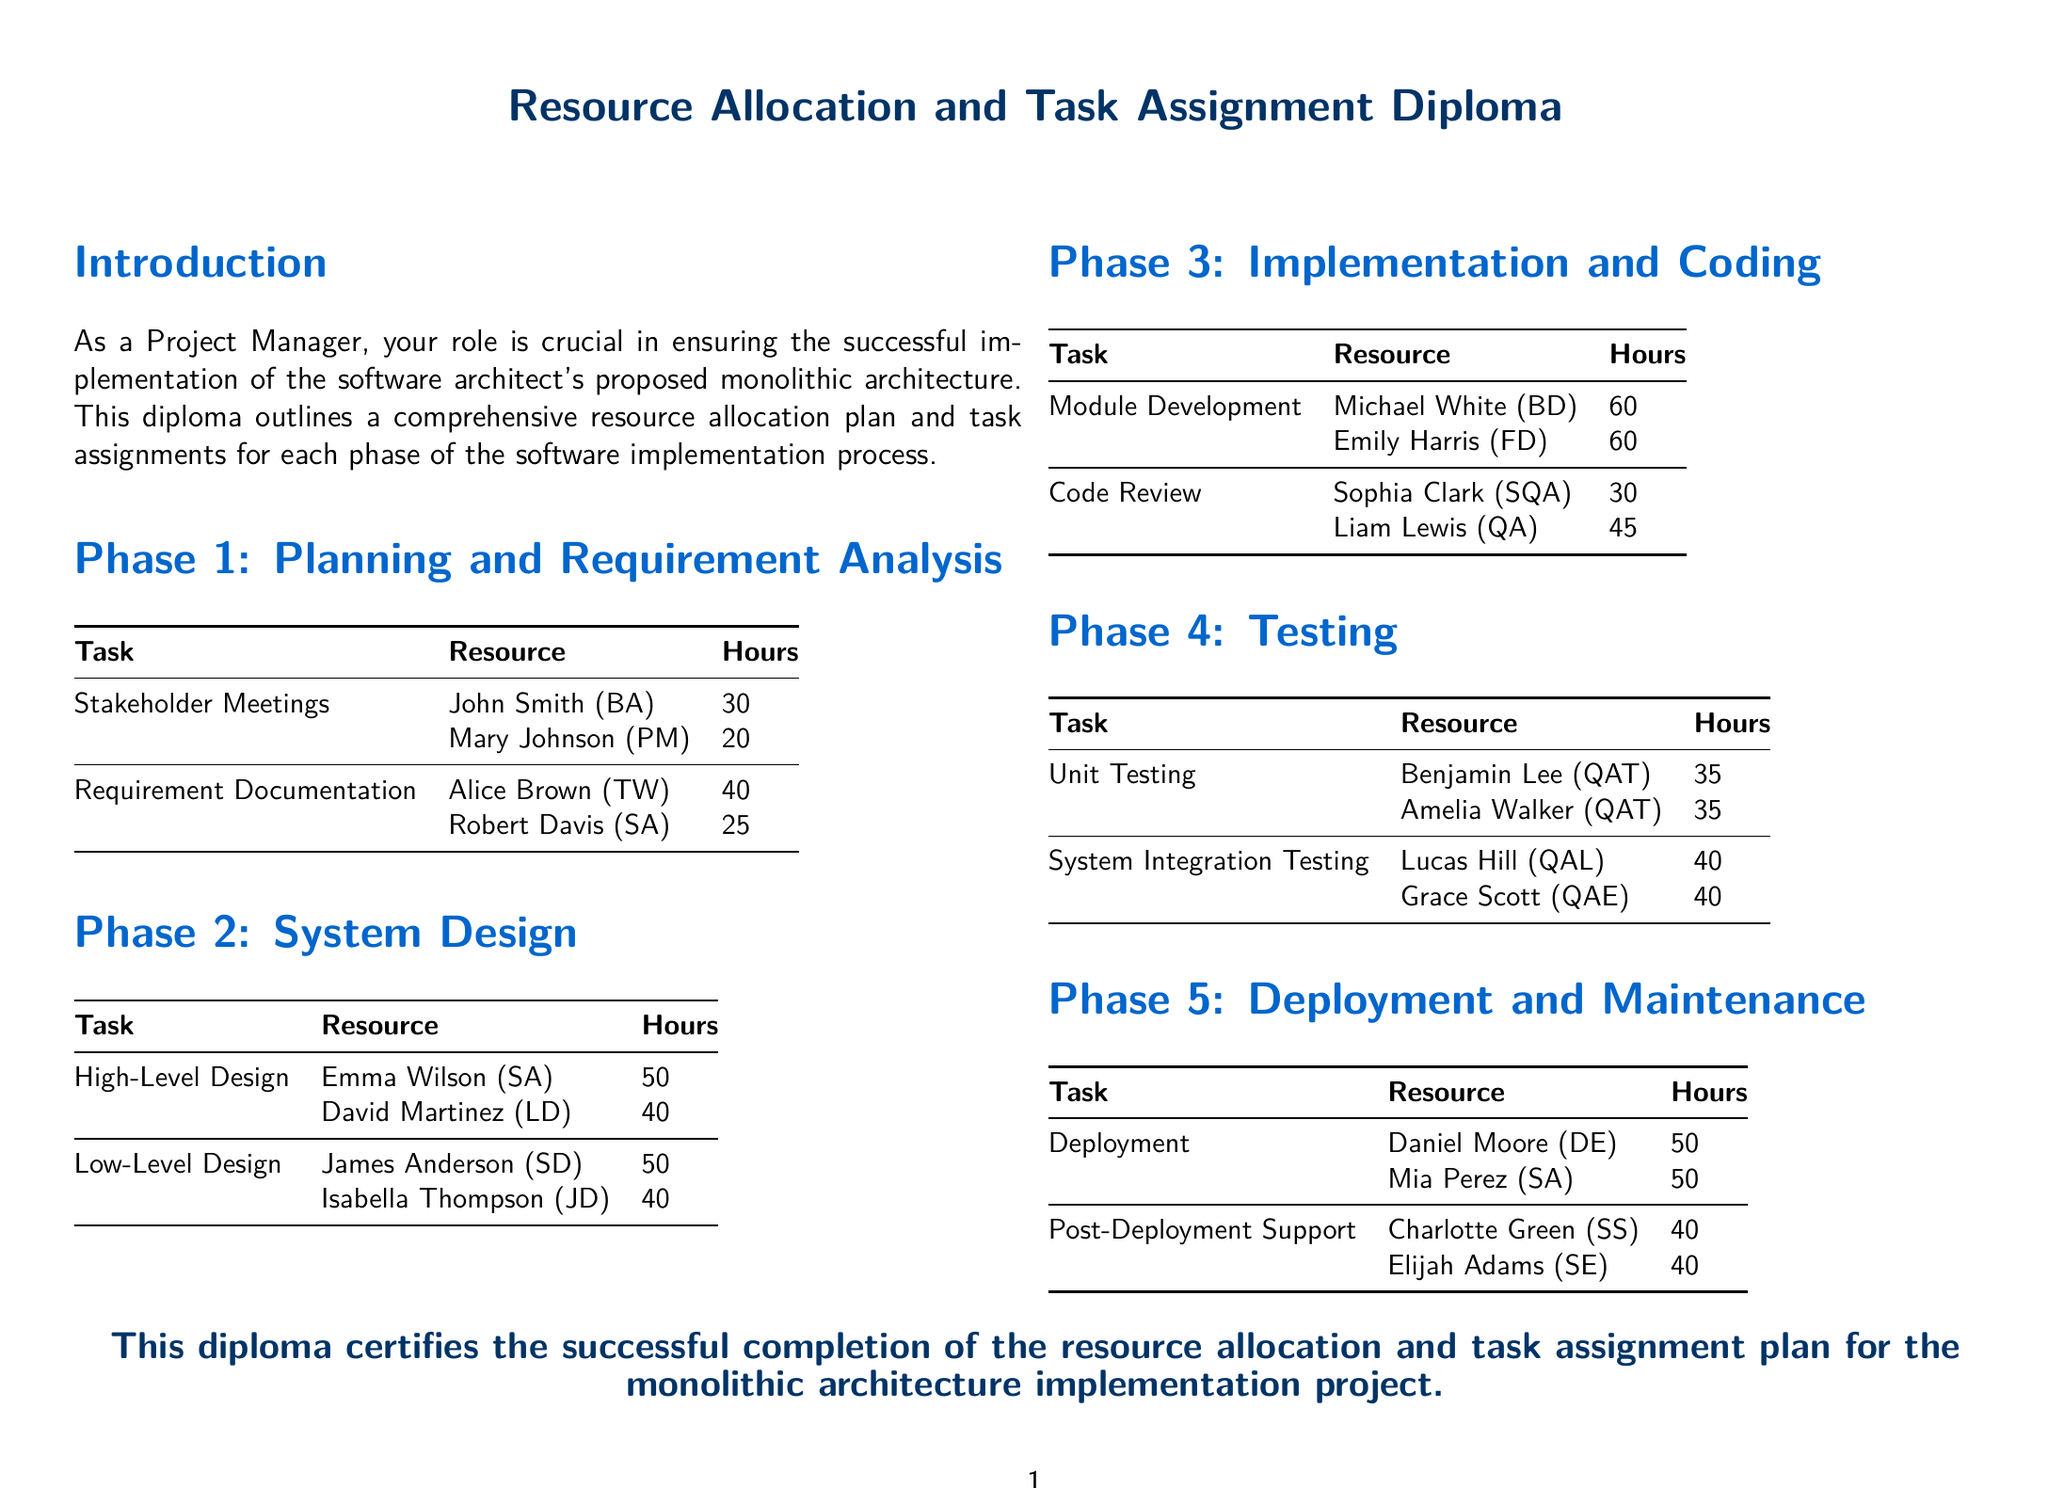what is the total number of hours for Requirement Documentation? The total number of hours for Requirement Documentation is calculated by adding 40 hours by Alice Brown and 25 hours by Robert Davis.
Answer: 65 who is responsible for Unit Testing? The document lists Benjamin Lee and Amelia Walker as responsible for Unit Testing.
Answer: Benjamin Lee, Amelia Walker how many hours are allocated for Deployment? The hours allocated for Deployment are found in the Deployment section, which states 50 hours by Daniel Moore and 50 hours by Mia Perez.
Answer: 100 what is the title of this document? The title of the document is presented prominently at the top.
Answer: Resource Allocation and Task Assignment Diploma how many tasks are listed in Phase 2: System Design? The number of tasks in Phase 2 can be counted in the table under that section.
Answer: 2 who is overseeing Code Review? The document specifies that Code Review is overseen by Sophia Clark and Liam Lewis.
Answer: Sophia Clark, Liam Lewis which phase has the most total hours assigned? Total hours assigned for all phases can be compared, focusing on Implementation and Coding, which contains 120 hours for Module Development and Code Review.
Answer: Implementation and Coding what role does Charlotte Green hold in Post-Deployment Support? The document indicates the specific roles of individuals in various tasks, including Charlotte Green's role.
Answer: SS how many hours are dedicated to System Integration Testing? The hours dedicated for System Integration Testing can be found in the Testing section.
Answer: 80 